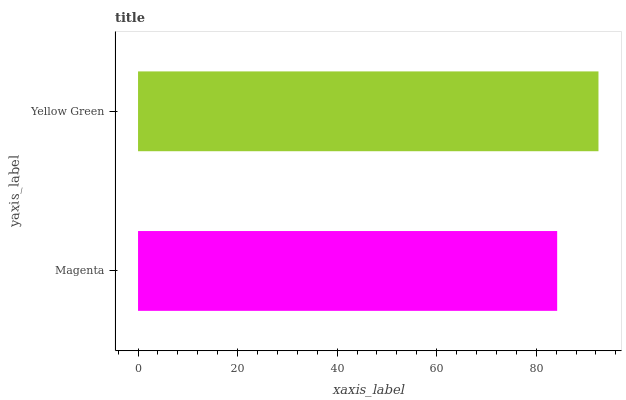Is Magenta the minimum?
Answer yes or no. Yes. Is Yellow Green the maximum?
Answer yes or no. Yes. Is Yellow Green the minimum?
Answer yes or no. No. Is Yellow Green greater than Magenta?
Answer yes or no. Yes. Is Magenta less than Yellow Green?
Answer yes or no. Yes. Is Magenta greater than Yellow Green?
Answer yes or no. No. Is Yellow Green less than Magenta?
Answer yes or no. No. Is Yellow Green the high median?
Answer yes or no. Yes. Is Magenta the low median?
Answer yes or no. Yes. Is Magenta the high median?
Answer yes or no. No. Is Yellow Green the low median?
Answer yes or no. No. 